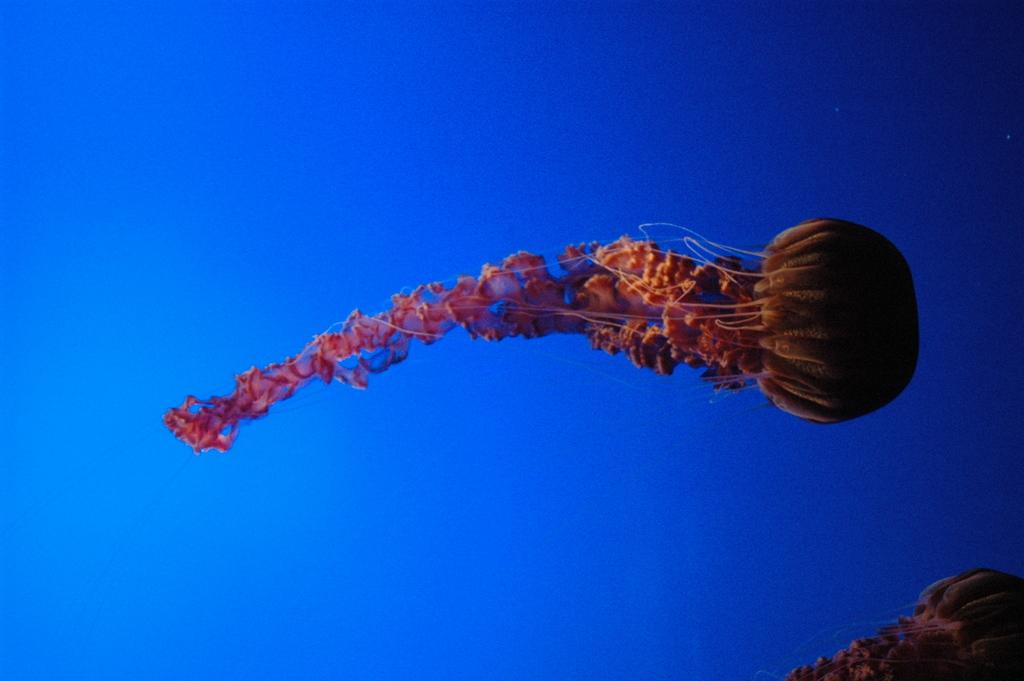What creatures are present in the image? There are two jellyfishes in the image. Where are the jellyfishes located? The jellyfishes are in the water. What is the income of the jellyfishes in the image? Jellyfishes do not have an income, as they are marine animals and not capable of earning money. 